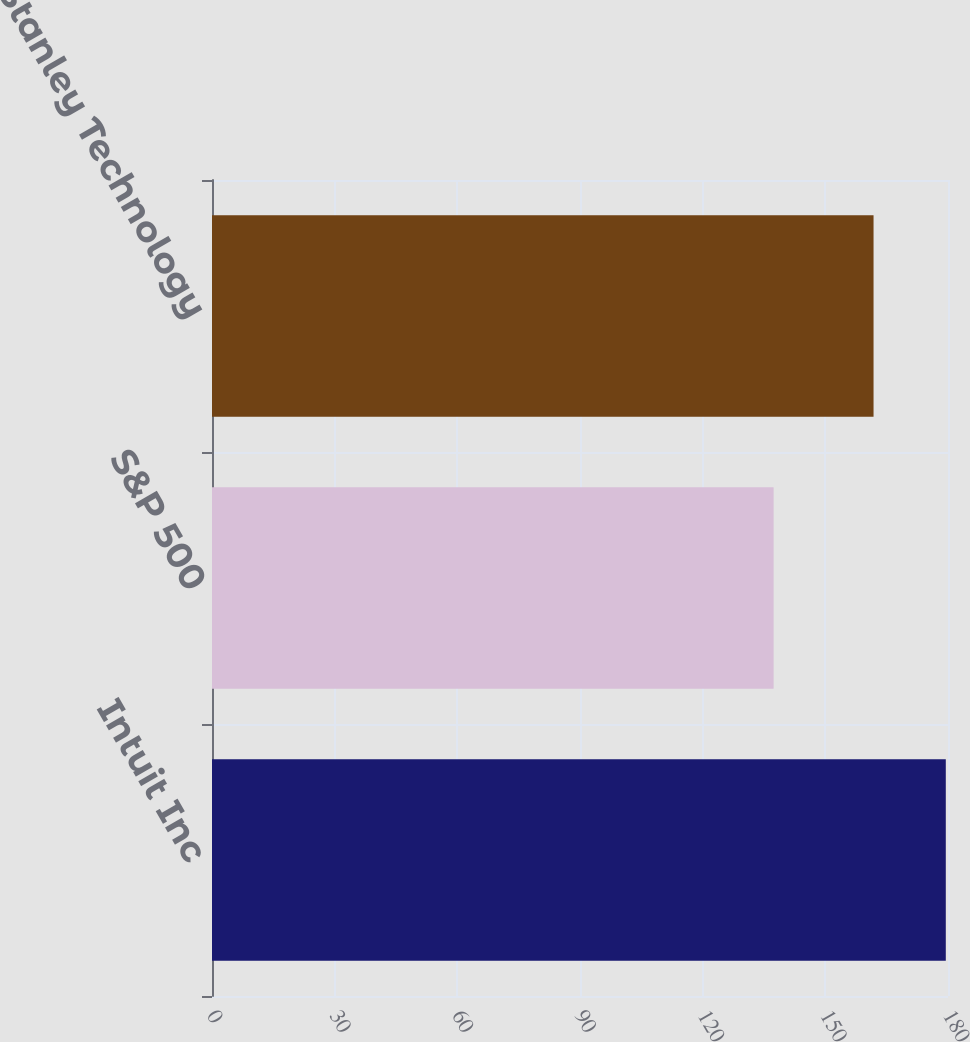Convert chart. <chart><loc_0><loc_0><loc_500><loc_500><bar_chart><fcel>Intuit Inc<fcel>S&P 500<fcel>Morgan Stanley Technology<nl><fcel>179.46<fcel>137.35<fcel>161.79<nl></chart> 